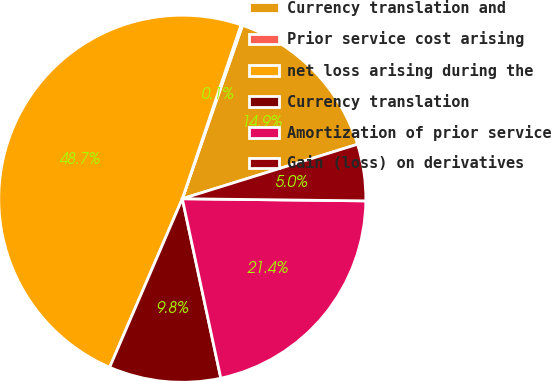Convert chart to OTSL. <chart><loc_0><loc_0><loc_500><loc_500><pie_chart><fcel>Currency translation and<fcel>Prior service cost arising<fcel>net loss arising during the<fcel>Currency translation<fcel>Amortization of prior service<fcel>Gain (loss) on derivatives<nl><fcel>14.89%<fcel>0.13%<fcel>48.71%<fcel>9.84%<fcel>21.45%<fcel>4.98%<nl></chart> 